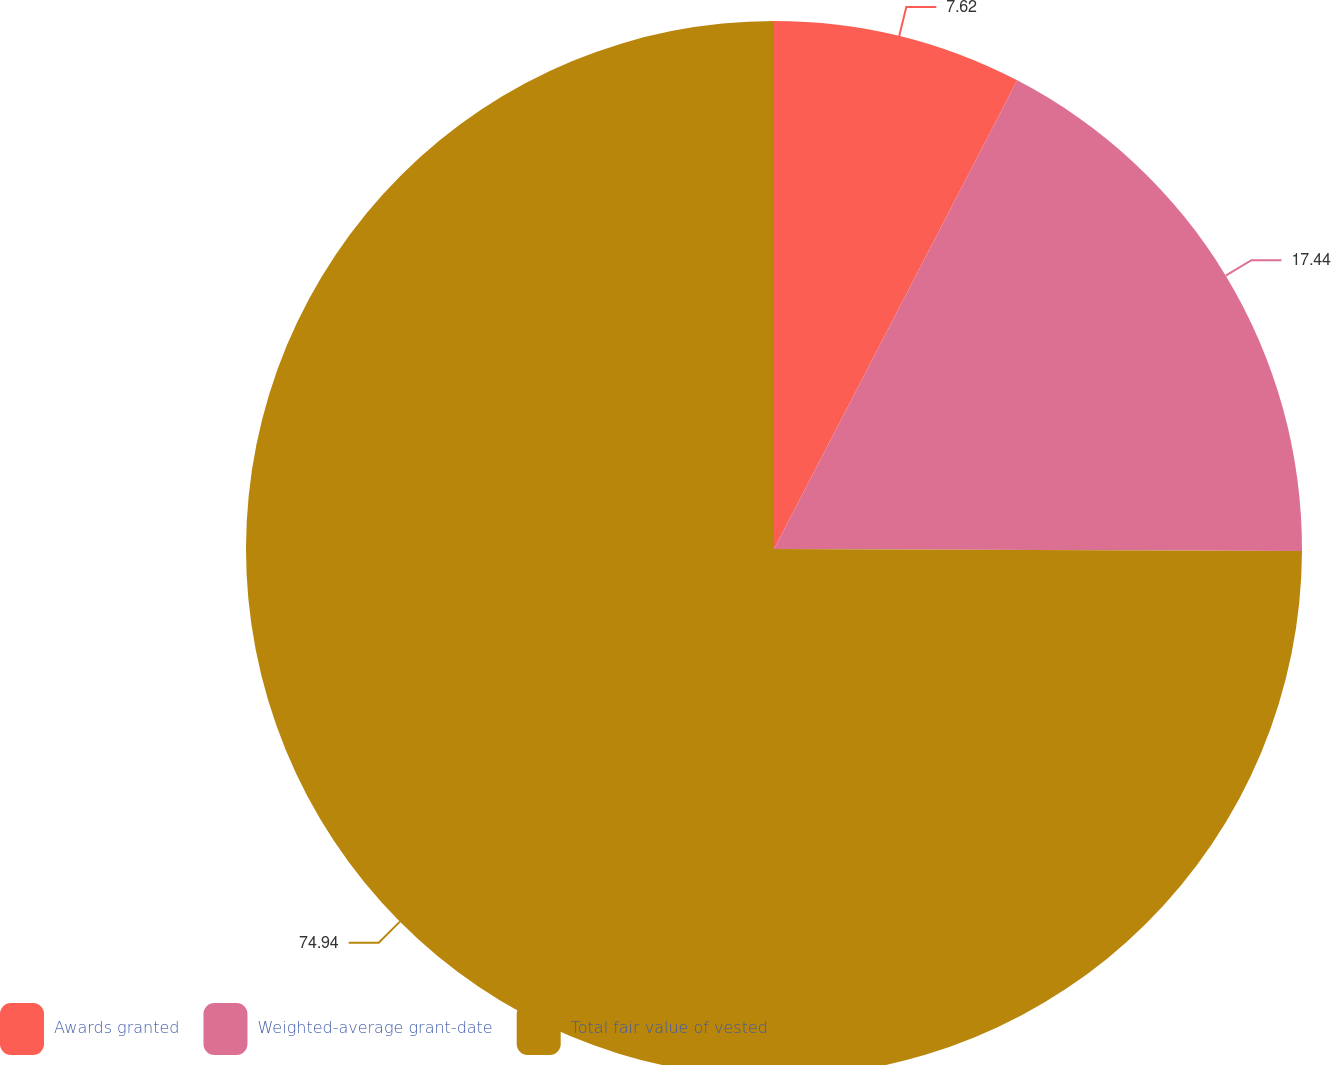Convert chart. <chart><loc_0><loc_0><loc_500><loc_500><pie_chart><fcel>Awards granted<fcel>Weighted-average grant-date<fcel>Total fair value of vested<nl><fcel>7.62%<fcel>17.44%<fcel>74.94%<nl></chart> 